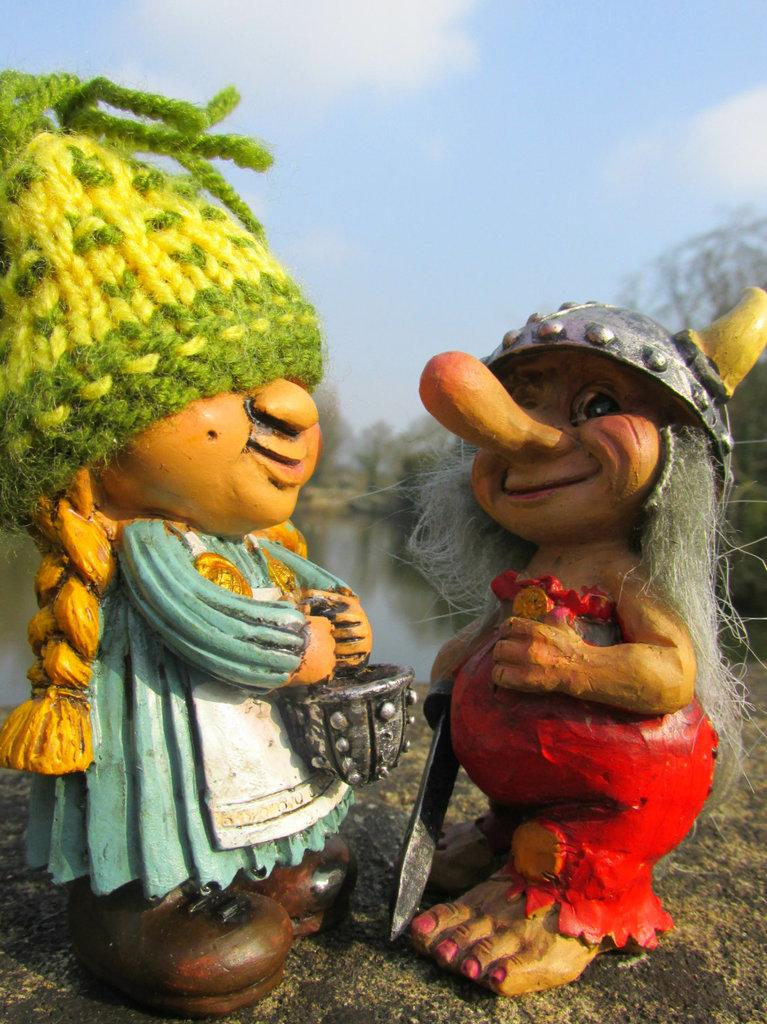What objects can be seen in the image? There are toys in the image. Where are the toys placed? The toys are kept on a stone. What can be seen in the background of the image? There is a lake and many trees visible in the background. What is visible at the top of the image? The sky is visible at the top of the image. What can be observed in the sky? Clouds are present in the sky. What type of curtain can be seen in the image? There is no curtain present in the image. 